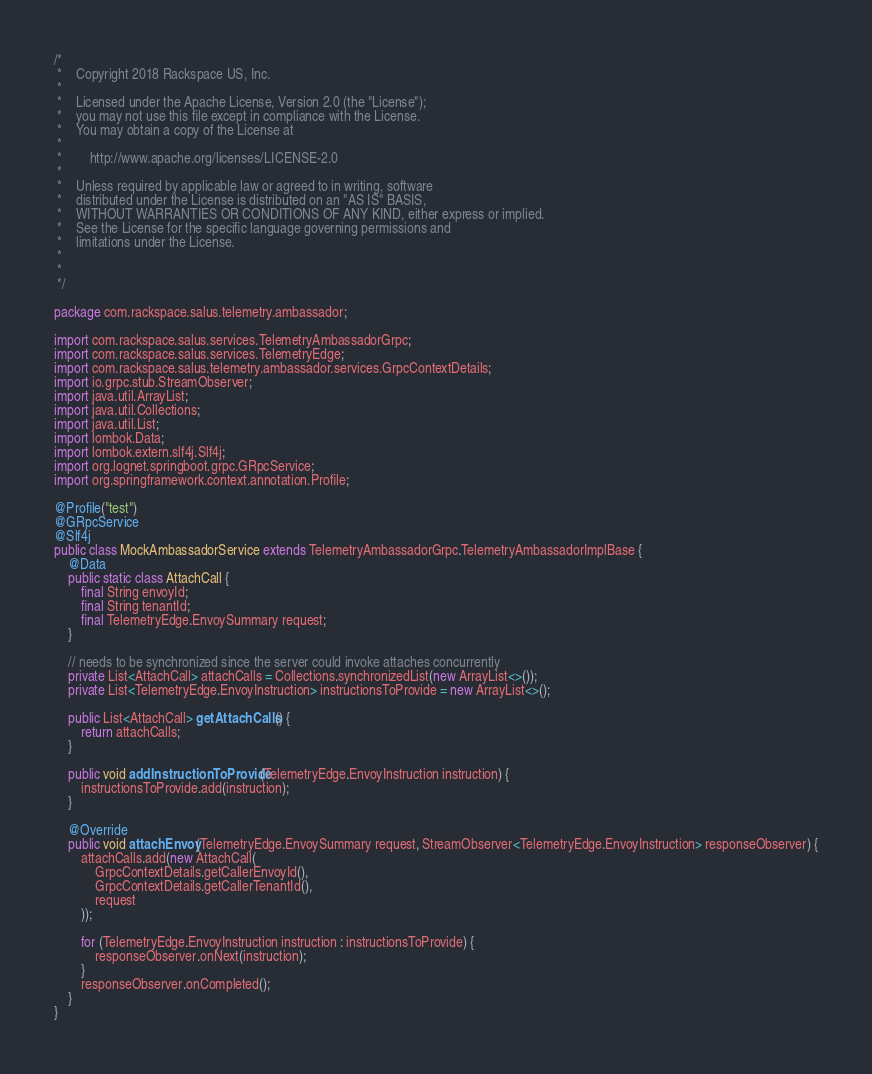<code> <loc_0><loc_0><loc_500><loc_500><_Java_>/*
 *    Copyright 2018 Rackspace US, Inc.
 *
 *    Licensed under the Apache License, Version 2.0 (the "License");
 *    you may not use this file except in compliance with the License.
 *    You may obtain a copy of the License at
 *
 *        http://www.apache.org/licenses/LICENSE-2.0
 *
 *    Unless required by applicable law or agreed to in writing, software
 *    distributed under the License is distributed on an "AS IS" BASIS,
 *    WITHOUT WARRANTIES OR CONDITIONS OF ANY KIND, either express or implied.
 *    See the License for the specific language governing permissions and
 *    limitations under the License.
 *
 *
 */

package com.rackspace.salus.telemetry.ambassador;

import com.rackspace.salus.services.TelemetryAmbassadorGrpc;
import com.rackspace.salus.services.TelemetryEdge;
import com.rackspace.salus.telemetry.ambassador.services.GrpcContextDetails;
import io.grpc.stub.StreamObserver;
import java.util.ArrayList;
import java.util.Collections;
import java.util.List;
import lombok.Data;
import lombok.extern.slf4j.Slf4j;
import org.lognet.springboot.grpc.GRpcService;
import org.springframework.context.annotation.Profile;

@Profile("test")
@GRpcService
@Slf4j
public class MockAmbassadorService extends TelemetryAmbassadorGrpc.TelemetryAmbassadorImplBase {
    @Data
    public static class AttachCall {
        final String envoyId;
        final String tenantId;
        final TelemetryEdge.EnvoySummary request;
    }

    // needs to be synchronized since the server could invoke attaches concurrently
    private List<AttachCall> attachCalls = Collections.synchronizedList(new ArrayList<>());
    private List<TelemetryEdge.EnvoyInstruction> instructionsToProvide = new ArrayList<>();

    public List<AttachCall> getAttachCalls() {
        return attachCalls;
    }

    public void addInstructionToProvide(TelemetryEdge.EnvoyInstruction instruction) {
        instructionsToProvide.add(instruction);
    }

    @Override
    public void attachEnvoy(TelemetryEdge.EnvoySummary request, StreamObserver<TelemetryEdge.EnvoyInstruction> responseObserver) {
        attachCalls.add(new AttachCall(
            GrpcContextDetails.getCallerEnvoyId(),
            GrpcContextDetails.getCallerTenantId(),
            request
        ));

        for (TelemetryEdge.EnvoyInstruction instruction : instructionsToProvide) {
            responseObserver.onNext(instruction);
        }
        responseObserver.onCompleted();
    }
}
</code> 